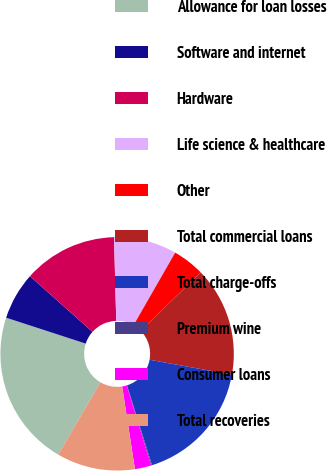<chart> <loc_0><loc_0><loc_500><loc_500><pie_chart><fcel>Allowance for loan losses<fcel>Software and internet<fcel>Hardware<fcel>Life science & healthcare<fcel>Other<fcel>Total commercial loans<fcel>Total charge-offs<fcel>Premium wine<fcel>Consumer loans<fcel>Total recoveries<nl><fcel>21.59%<fcel>6.57%<fcel>13.0%<fcel>8.71%<fcel>4.42%<fcel>15.15%<fcel>17.3%<fcel>0.13%<fcel>2.27%<fcel>10.86%<nl></chart> 